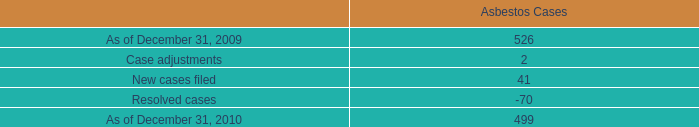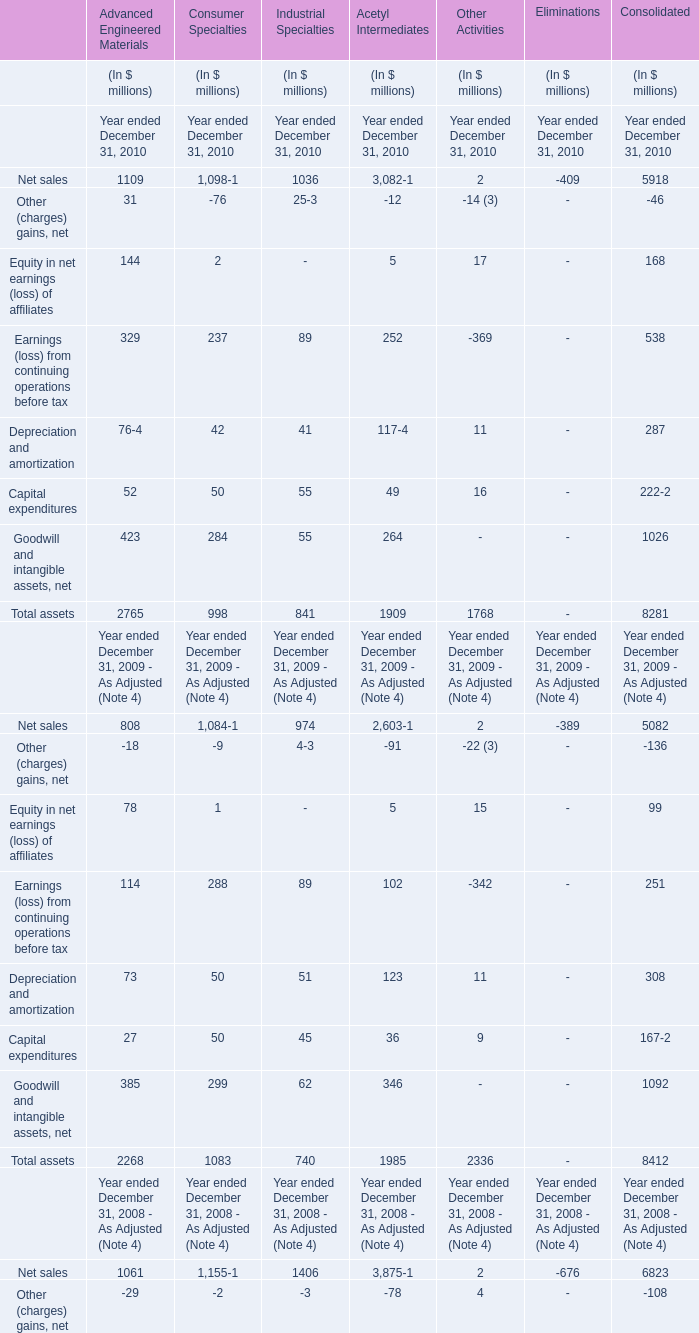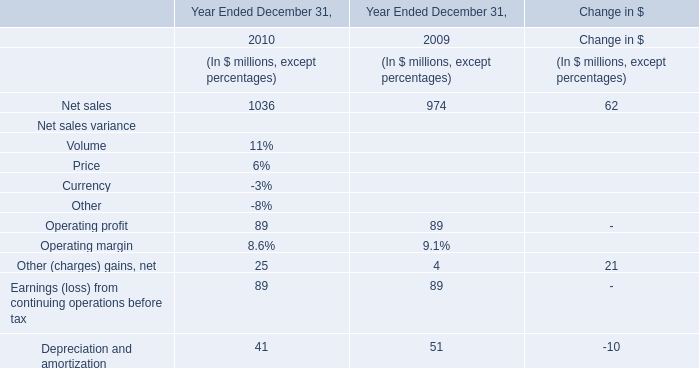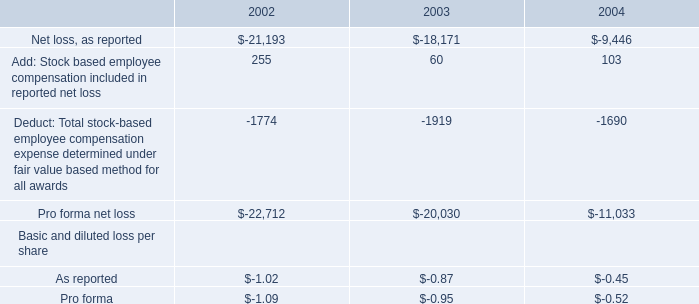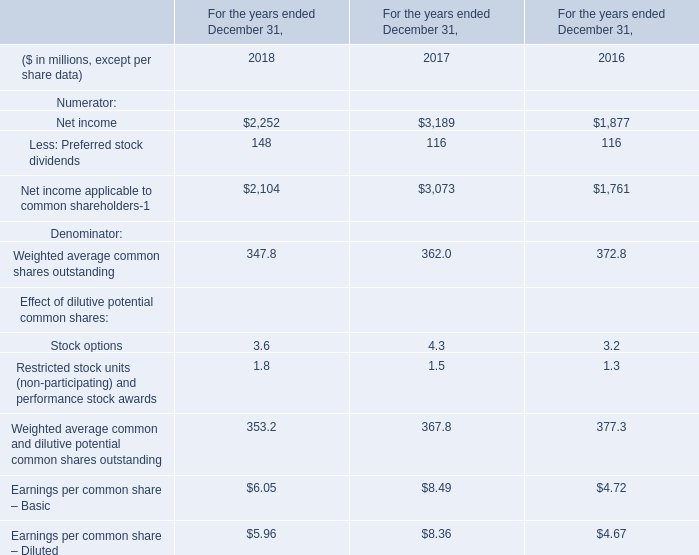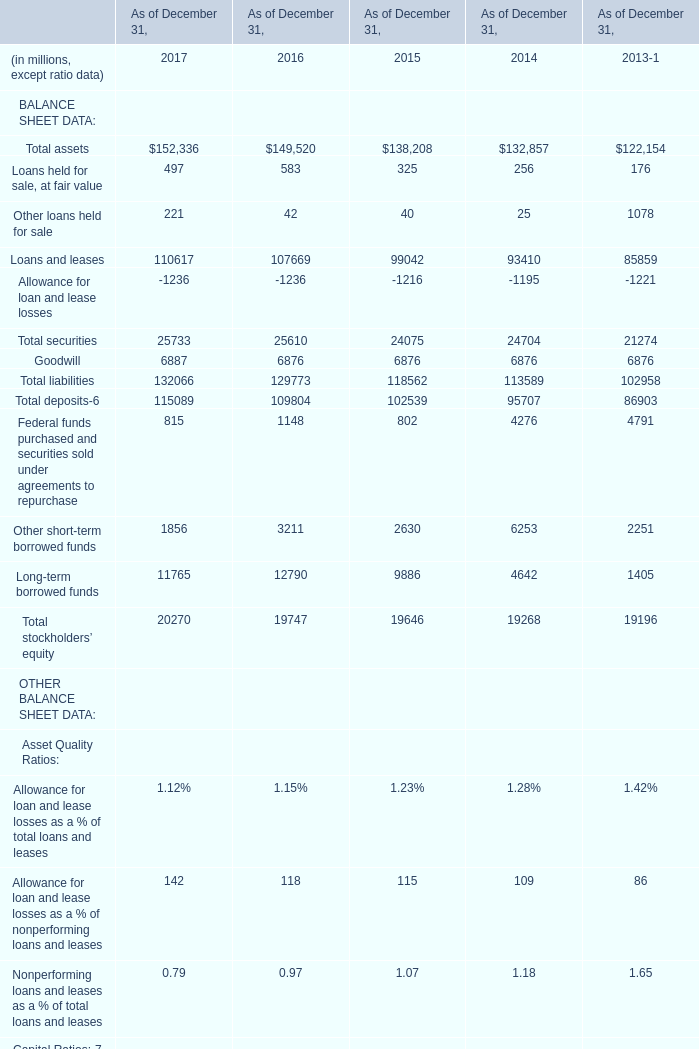What's the sum of Goodwill of As of December 31, 2017, and Net income of For the years ended December 31, 2016 ? 
Computations: (6887.0 + 1877.0)
Answer: 8764.0. 